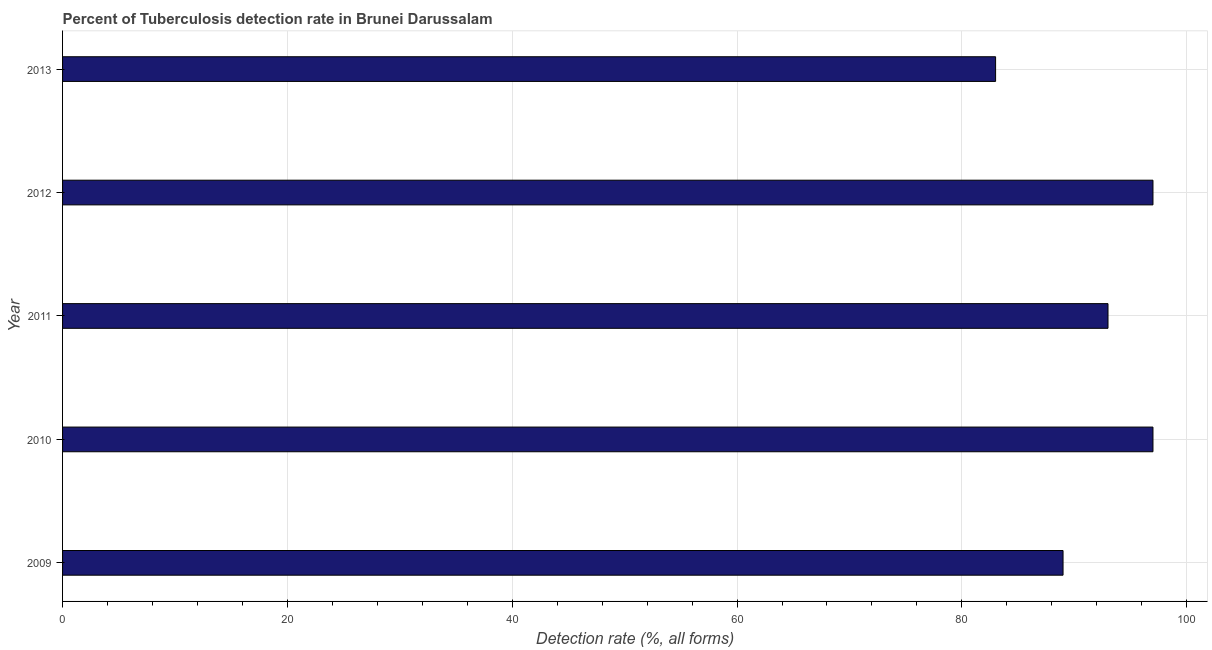Does the graph contain grids?
Your answer should be very brief. Yes. What is the title of the graph?
Your answer should be very brief. Percent of Tuberculosis detection rate in Brunei Darussalam. What is the label or title of the X-axis?
Provide a succinct answer. Detection rate (%, all forms). What is the detection rate of tuberculosis in 2011?
Make the answer very short. 93. Across all years, what is the maximum detection rate of tuberculosis?
Keep it short and to the point. 97. What is the sum of the detection rate of tuberculosis?
Your answer should be compact. 459. What is the average detection rate of tuberculosis per year?
Ensure brevity in your answer.  91. What is the median detection rate of tuberculosis?
Offer a terse response. 93. In how many years, is the detection rate of tuberculosis greater than 88 %?
Ensure brevity in your answer.  4. Do a majority of the years between 2011 and 2012 (inclusive) have detection rate of tuberculosis greater than 32 %?
Give a very brief answer. Yes. What is the ratio of the detection rate of tuberculosis in 2012 to that in 2013?
Your answer should be very brief. 1.17. What is the difference between the highest and the lowest detection rate of tuberculosis?
Provide a short and direct response. 14. How many bars are there?
Your answer should be very brief. 5. How many years are there in the graph?
Offer a terse response. 5. What is the difference between two consecutive major ticks on the X-axis?
Ensure brevity in your answer.  20. What is the Detection rate (%, all forms) of 2009?
Keep it short and to the point. 89. What is the Detection rate (%, all forms) of 2010?
Ensure brevity in your answer.  97. What is the Detection rate (%, all forms) in 2011?
Your response must be concise. 93. What is the Detection rate (%, all forms) of 2012?
Give a very brief answer. 97. What is the Detection rate (%, all forms) in 2013?
Your response must be concise. 83. What is the difference between the Detection rate (%, all forms) in 2009 and 2010?
Your answer should be compact. -8. What is the difference between the Detection rate (%, all forms) in 2009 and 2011?
Provide a short and direct response. -4. What is the difference between the Detection rate (%, all forms) in 2009 and 2012?
Provide a succinct answer. -8. What is the difference between the Detection rate (%, all forms) in 2009 and 2013?
Provide a short and direct response. 6. What is the difference between the Detection rate (%, all forms) in 2010 and 2011?
Make the answer very short. 4. What is the difference between the Detection rate (%, all forms) in 2010 and 2012?
Ensure brevity in your answer.  0. What is the difference between the Detection rate (%, all forms) in 2010 and 2013?
Your answer should be very brief. 14. What is the difference between the Detection rate (%, all forms) in 2011 and 2012?
Provide a succinct answer. -4. What is the ratio of the Detection rate (%, all forms) in 2009 to that in 2010?
Your answer should be very brief. 0.92. What is the ratio of the Detection rate (%, all forms) in 2009 to that in 2011?
Keep it short and to the point. 0.96. What is the ratio of the Detection rate (%, all forms) in 2009 to that in 2012?
Ensure brevity in your answer.  0.92. What is the ratio of the Detection rate (%, all forms) in 2009 to that in 2013?
Give a very brief answer. 1.07. What is the ratio of the Detection rate (%, all forms) in 2010 to that in 2011?
Your response must be concise. 1.04. What is the ratio of the Detection rate (%, all forms) in 2010 to that in 2012?
Your response must be concise. 1. What is the ratio of the Detection rate (%, all forms) in 2010 to that in 2013?
Provide a short and direct response. 1.17. What is the ratio of the Detection rate (%, all forms) in 2011 to that in 2012?
Offer a terse response. 0.96. What is the ratio of the Detection rate (%, all forms) in 2011 to that in 2013?
Your answer should be compact. 1.12. What is the ratio of the Detection rate (%, all forms) in 2012 to that in 2013?
Your answer should be compact. 1.17. 